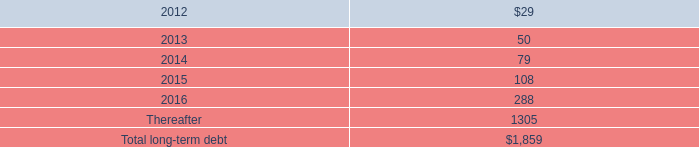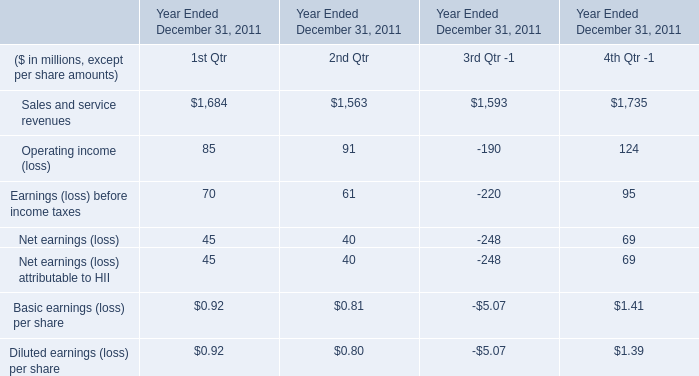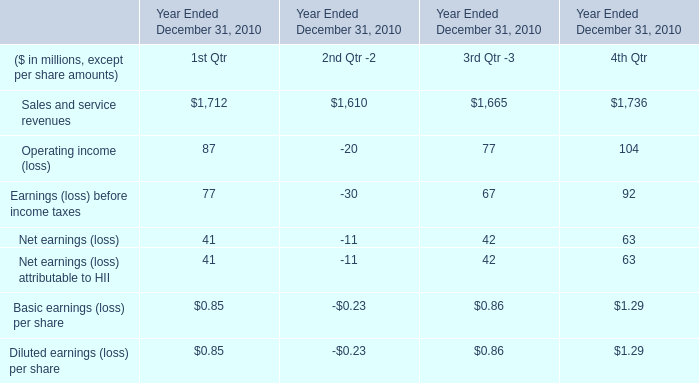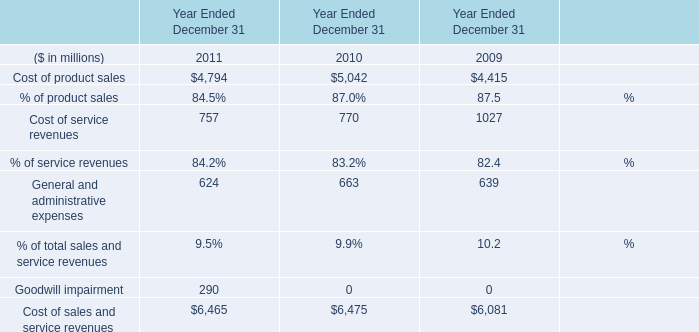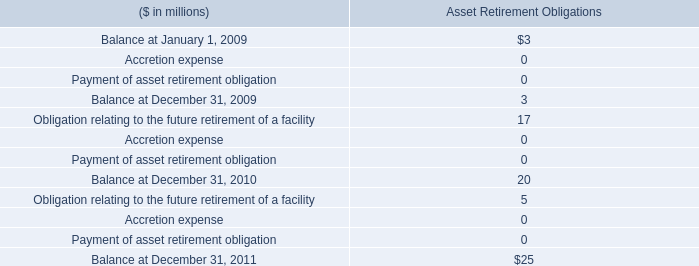what was the percentage reduction in the shut down related costs as presented to the dod 
Computations: ((271 - 310) / 310)
Answer: -0.12581. 